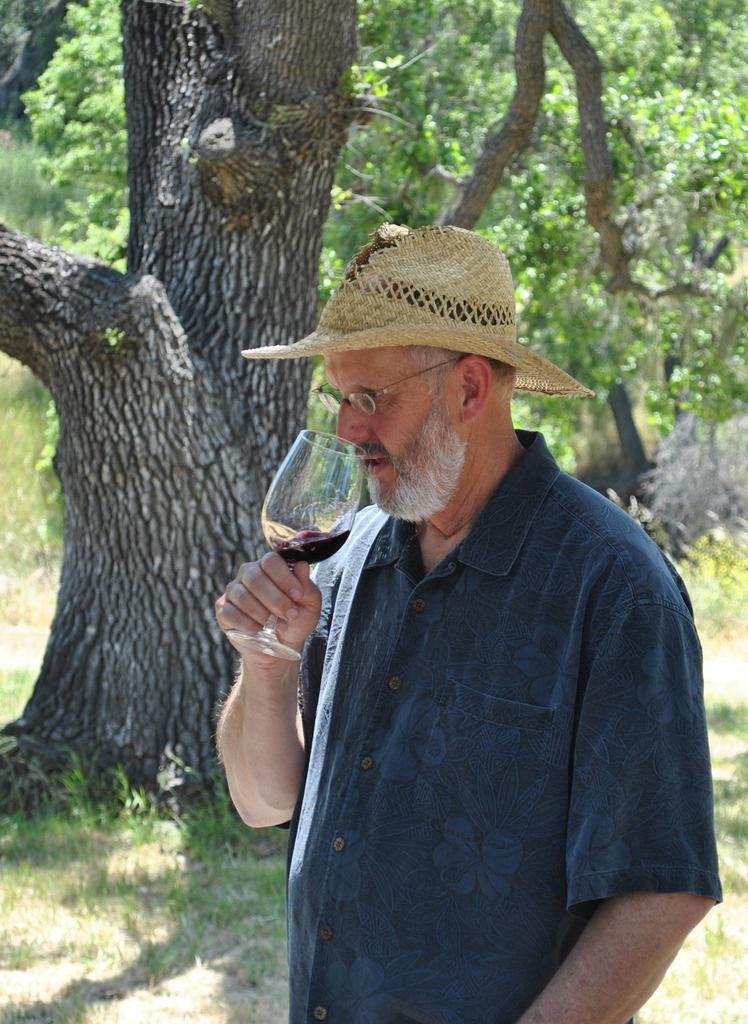What is the main subject of the image? There is a person in the image. What is the person wearing in the image? The person is wearing a blue shirt. What activity is the person engaged in? The person is drinking a glass of wine. What can be seen in the background of the image? There are trees in the background of the image. What type of impulse can be seen affecting the person's decision to drink the wine in the image? There is no indication in the image of any impulse affecting the person's decision to drink the wine. What type of ring is the person wearing on their finger in the image? There is no ring visible on the person's finger in the image. 